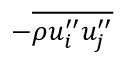Convert formula to latex. <formula><loc_0><loc_0><loc_500><loc_500>- \overline { { \rho u _ { i } ^ { \prime \prime } u _ { j } ^ { \prime \prime } } }</formula> 